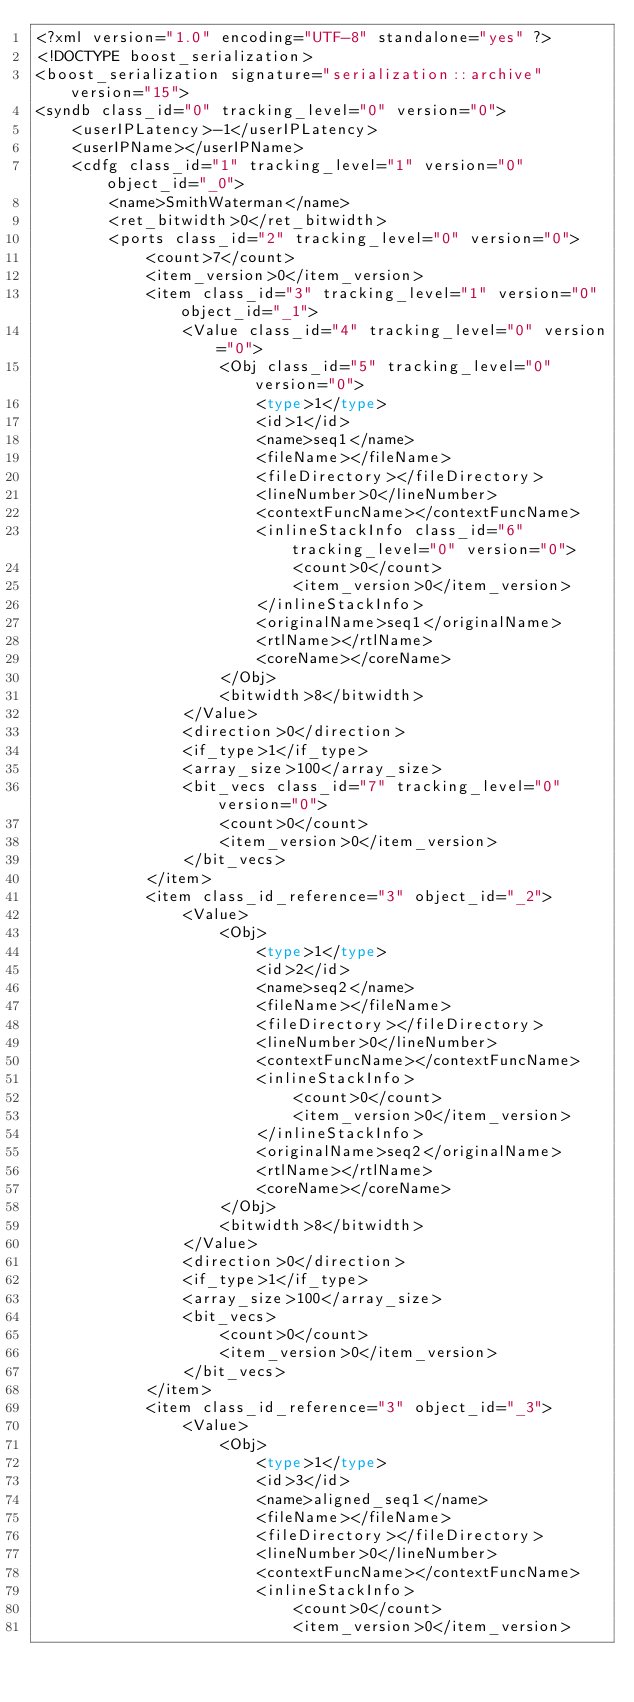<code> <loc_0><loc_0><loc_500><loc_500><_Ada_><?xml version="1.0" encoding="UTF-8" standalone="yes" ?>
<!DOCTYPE boost_serialization>
<boost_serialization signature="serialization::archive" version="15">
<syndb class_id="0" tracking_level="0" version="0">
	<userIPLatency>-1</userIPLatency>
	<userIPName></userIPName>
	<cdfg class_id="1" tracking_level="1" version="0" object_id="_0">
		<name>SmithWaterman</name>
		<ret_bitwidth>0</ret_bitwidth>
		<ports class_id="2" tracking_level="0" version="0">
			<count>7</count>
			<item_version>0</item_version>
			<item class_id="3" tracking_level="1" version="0" object_id="_1">
				<Value class_id="4" tracking_level="0" version="0">
					<Obj class_id="5" tracking_level="0" version="0">
						<type>1</type>
						<id>1</id>
						<name>seq1</name>
						<fileName></fileName>
						<fileDirectory></fileDirectory>
						<lineNumber>0</lineNumber>
						<contextFuncName></contextFuncName>
						<inlineStackInfo class_id="6" tracking_level="0" version="0">
							<count>0</count>
							<item_version>0</item_version>
						</inlineStackInfo>
						<originalName>seq1</originalName>
						<rtlName></rtlName>
						<coreName></coreName>
					</Obj>
					<bitwidth>8</bitwidth>
				</Value>
				<direction>0</direction>
				<if_type>1</if_type>
				<array_size>100</array_size>
				<bit_vecs class_id="7" tracking_level="0" version="0">
					<count>0</count>
					<item_version>0</item_version>
				</bit_vecs>
			</item>
			<item class_id_reference="3" object_id="_2">
				<Value>
					<Obj>
						<type>1</type>
						<id>2</id>
						<name>seq2</name>
						<fileName></fileName>
						<fileDirectory></fileDirectory>
						<lineNumber>0</lineNumber>
						<contextFuncName></contextFuncName>
						<inlineStackInfo>
							<count>0</count>
							<item_version>0</item_version>
						</inlineStackInfo>
						<originalName>seq2</originalName>
						<rtlName></rtlName>
						<coreName></coreName>
					</Obj>
					<bitwidth>8</bitwidth>
				</Value>
				<direction>0</direction>
				<if_type>1</if_type>
				<array_size>100</array_size>
				<bit_vecs>
					<count>0</count>
					<item_version>0</item_version>
				</bit_vecs>
			</item>
			<item class_id_reference="3" object_id="_3">
				<Value>
					<Obj>
						<type>1</type>
						<id>3</id>
						<name>aligned_seq1</name>
						<fileName></fileName>
						<fileDirectory></fileDirectory>
						<lineNumber>0</lineNumber>
						<contextFuncName></contextFuncName>
						<inlineStackInfo>
							<count>0</count>
							<item_version>0</item_version></code> 